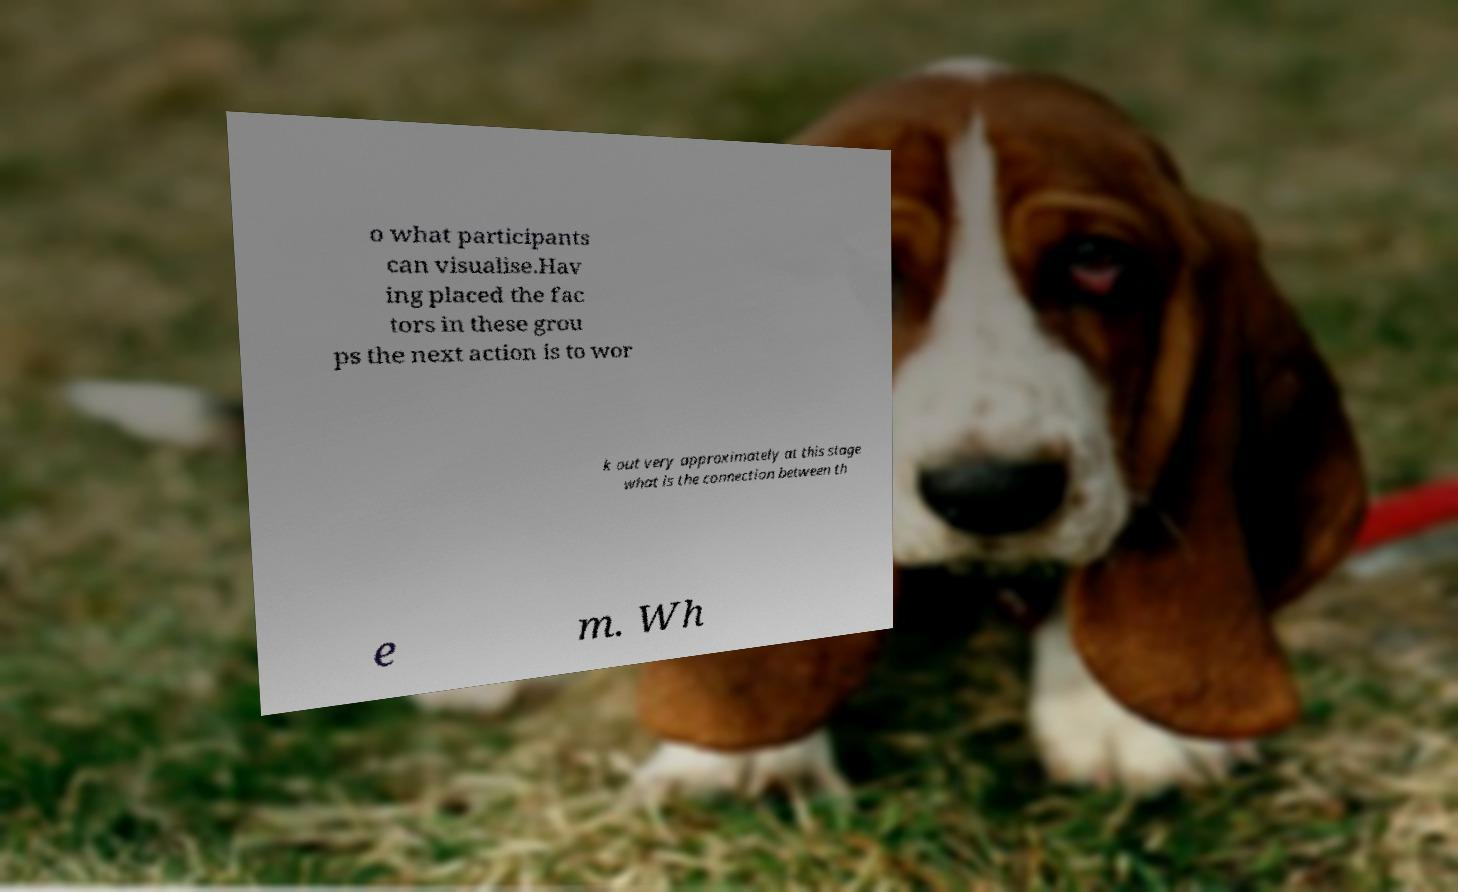For documentation purposes, I need the text within this image transcribed. Could you provide that? o what participants can visualise.Hav ing placed the fac tors in these grou ps the next action is to wor k out very approximately at this stage what is the connection between th e m. Wh 